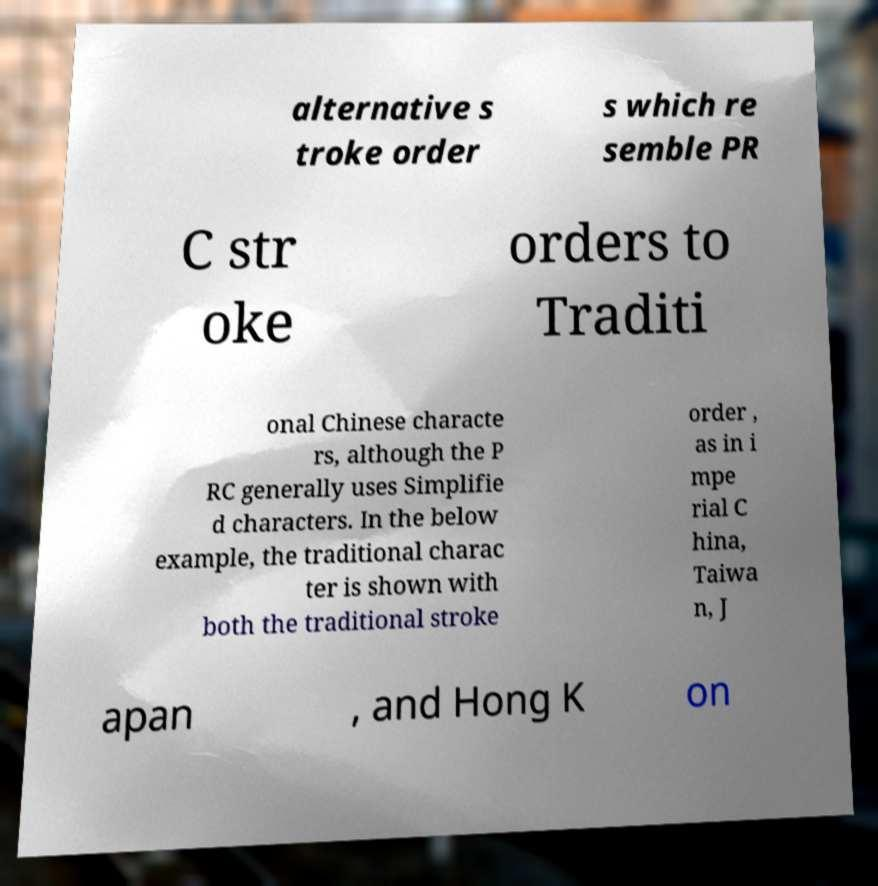Please read and relay the text visible in this image. What does it say? alternative s troke order s which re semble PR C str oke orders to Traditi onal Chinese characte rs, although the P RC generally uses Simplifie d characters. In the below example, the traditional charac ter is shown with both the traditional stroke order , as in i mpe rial C hina, Taiwa n, J apan , and Hong K on 